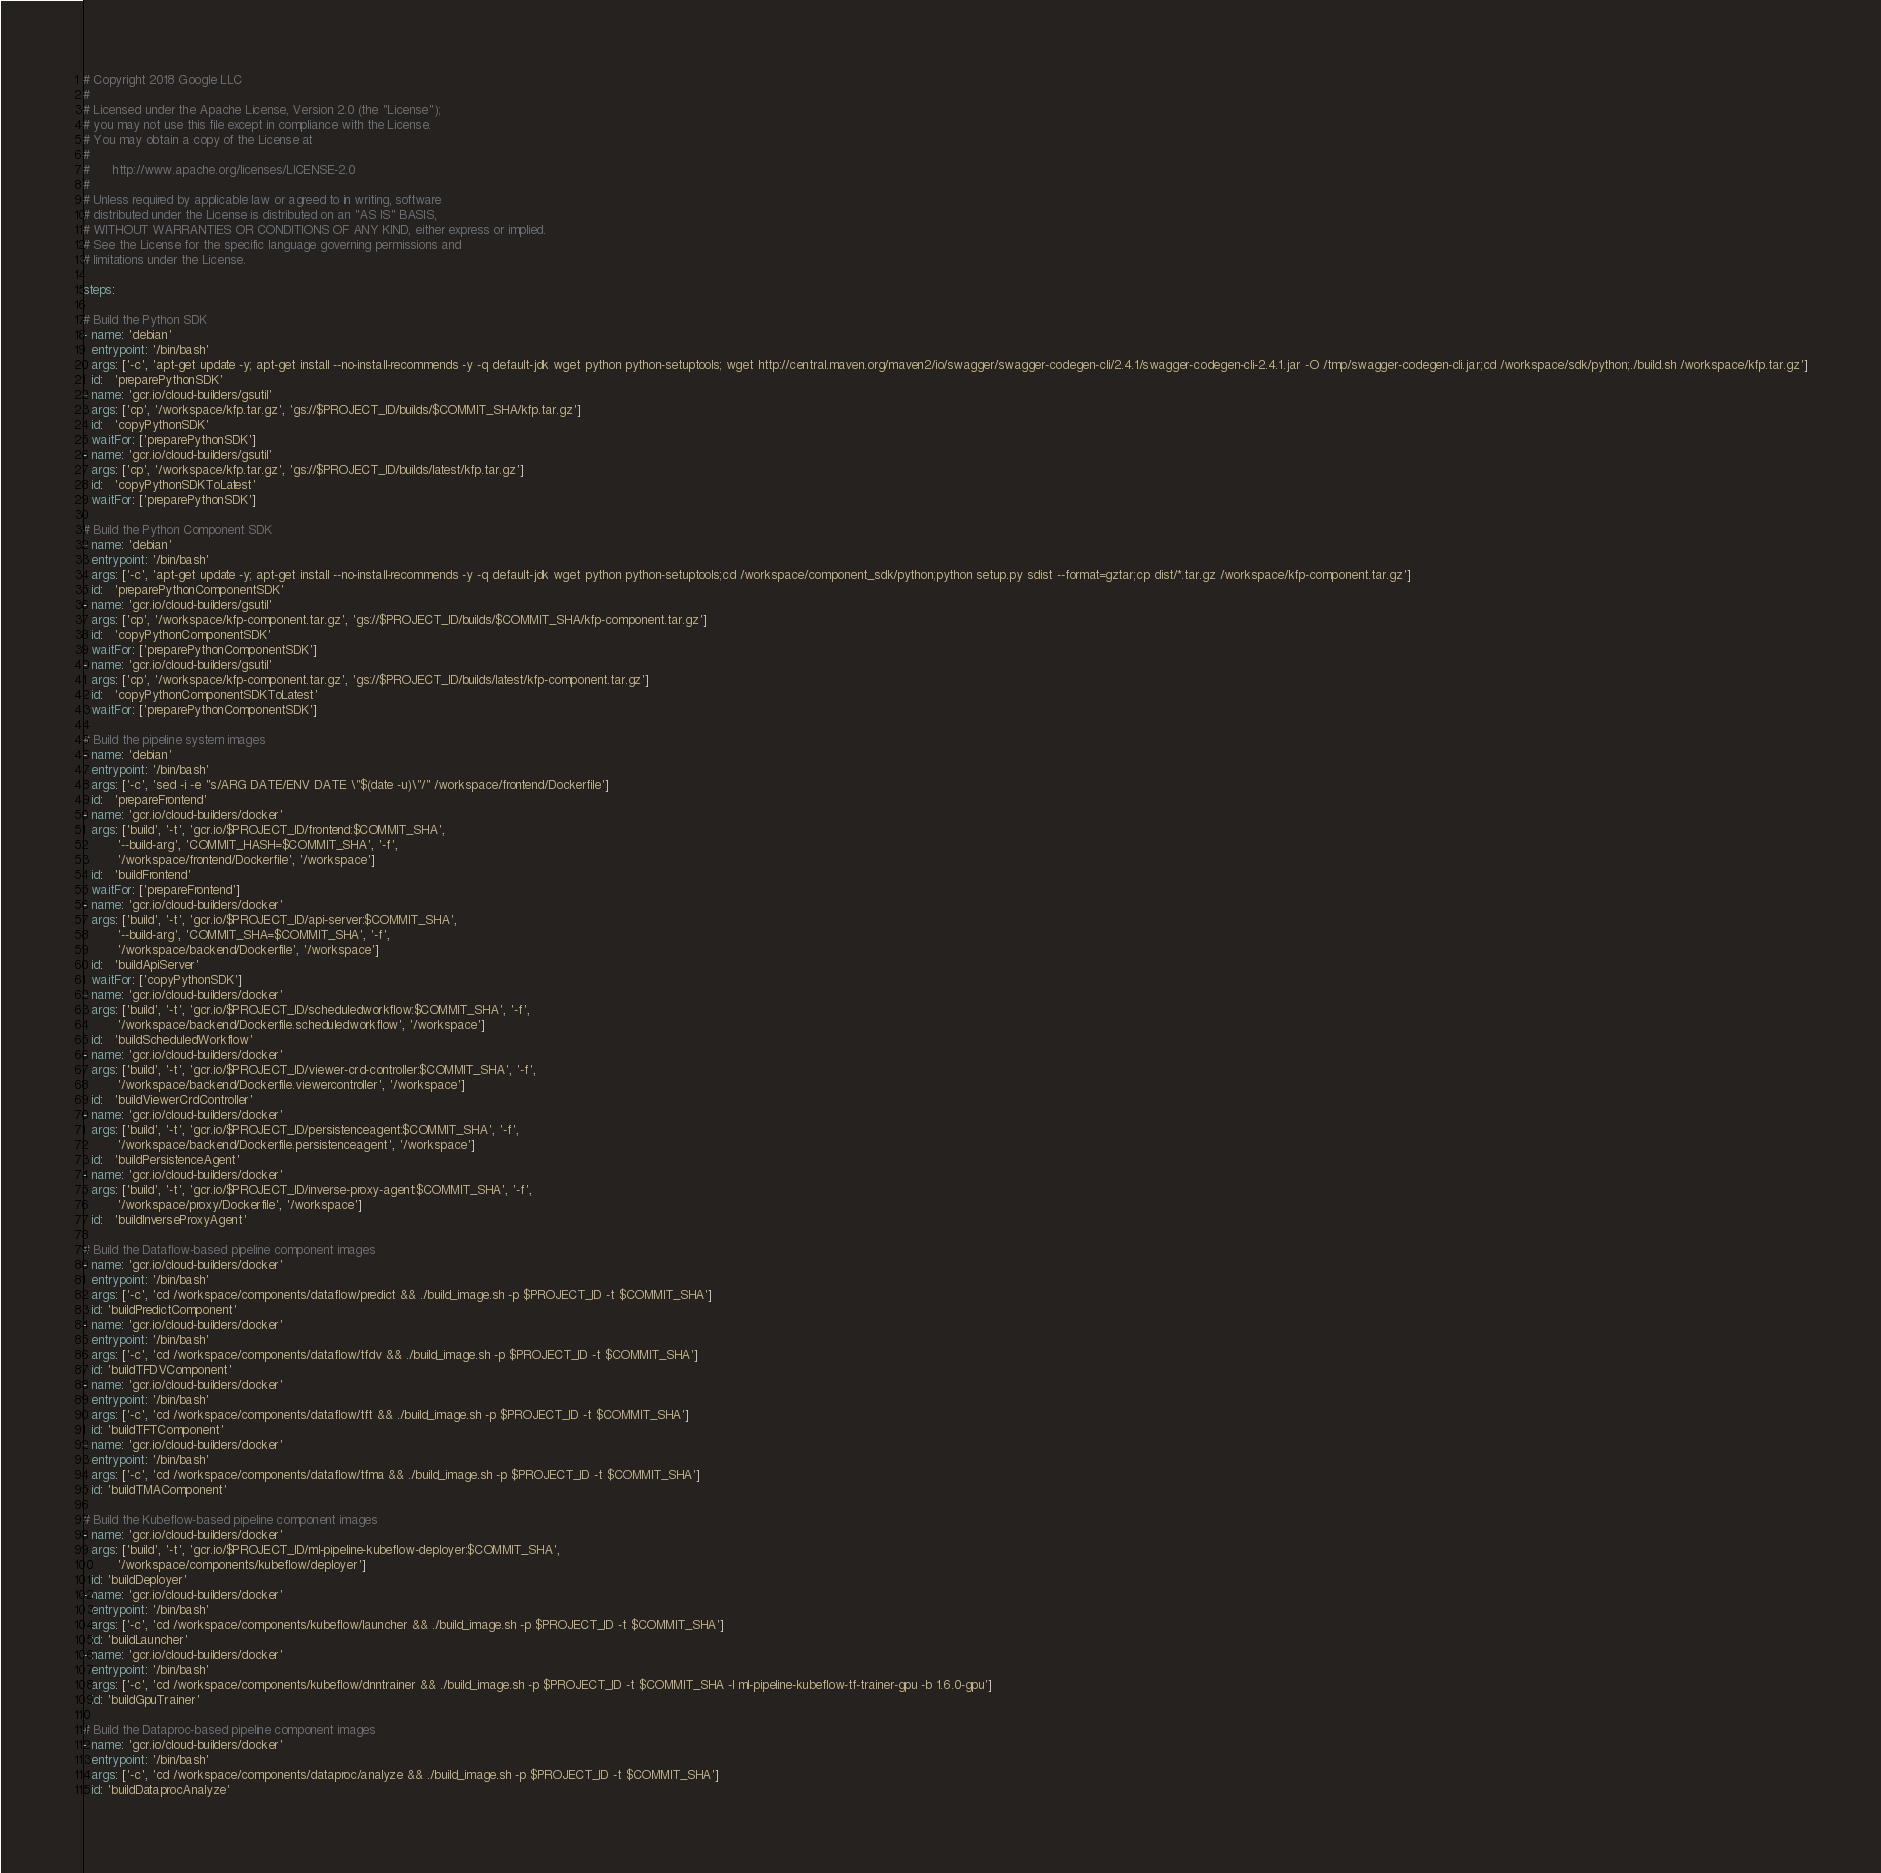Convert code to text. <code><loc_0><loc_0><loc_500><loc_500><_YAML_># Copyright 2018 Google LLC
#
# Licensed under the Apache License, Version 2.0 (the "License");
# you may not use this file except in compliance with the License.
# You may obtain a copy of the License at
#
#      http://www.apache.org/licenses/LICENSE-2.0
#
# Unless required by applicable law or agreed to in writing, software
# distributed under the License is distributed on an "AS IS" BASIS,
# WITHOUT WARRANTIES OR CONDITIONS OF ANY KIND, either express or implied.
# See the License for the specific language governing permissions and
# limitations under the License.

steps:

# Build the Python SDK
- name: 'debian'
  entrypoint: '/bin/bash'
  args: ['-c', 'apt-get update -y; apt-get install --no-install-recommends -y -q default-jdk wget python python-setuptools; wget http://central.maven.org/maven2/io/swagger/swagger-codegen-cli/2.4.1/swagger-codegen-cli-2.4.1.jar -O /tmp/swagger-codegen-cli.jar;cd /workspace/sdk/python;./build.sh /workspace/kfp.tar.gz']
  id:   'preparePythonSDK'
- name: 'gcr.io/cloud-builders/gsutil'
  args: ['cp', '/workspace/kfp.tar.gz', 'gs://$PROJECT_ID/builds/$COMMIT_SHA/kfp.tar.gz']
  id:   'copyPythonSDK'
  waitFor: ['preparePythonSDK']
- name: 'gcr.io/cloud-builders/gsutil'
  args: ['cp', '/workspace/kfp.tar.gz', 'gs://$PROJECT_ID/builds/latest/kfp.tar.gz']
  id:   'copyPythonSDKToLatest'
  waitFor: ['preparePythonSDK']

# Build the Python Component SDK
- name: 'debian'
  entrypoint: '/bin/bash'
  args: ['-c', 'apt-get update -y; apt-get install --no-install-recommends -y -q default-jdk wget python python-setuptools;cd /workspace/component_sdk/python;python setup.py sdist --format=gztar;cp dist/*.tar.gz /workspace/kfp-component.tar.gz']
  id:   'preparePythonComponentSDK'
- name: 'gcr.io/cloud-builders/gsutil'
  args: ['cp', '/workspace/kfp-component.tar.gz', 'gs://$PROJECT_ID/builds/$COMMIT_SHA/kfp-component.tar.gz']
  id:   'copyPythonComponentSDK'
  waitFor: ['preparePythonComponentSDK']
- name: 'gcr.io/cloud-builders/gsutil'
  args: ['cp', '/workspace/kfp-component.tar.gz', 'gs://$PROJECT_ID/builds/latest/kfp-component.tar.gz']
  id:   'copyPythonComponentSDKToLatest'
  waitFor: ['preparePythonComponentSDK']

# Build the pipeline system images
- name: 'debian'
  entrypoint: '/bin/bash'
  args: ['-c', 'sed -i -e "s/ARG DATE/ENV DATE \"$(date -u)\"/" /workspace/frontend/Dockerfile']
  id:   'prepareFrontend'
- name: 'gcr.io/cloud-builders/docker'
  args: ['build', '-t', 'gcr.io/$PROJECT_ID/frontend:$COMMIT_SHA',
         '--build-arg', 'COMMIT_HASH=$COMMIT_SHA', '-f',
         '/workspace/frontend/Dockerfile', '/workspace']
  id:   'buildFrontend'
  waitFor: ['prepareFrontend']
- name: 'gcr.io/cloud-builders/docker'
  args: ['build', '-t', 'gcr.io/$PROJECT_ID/api-server:$COMMIT_SHA',
         '--build-arg', 'COMMIT_SHA=$COMMIT_SHA', '-f',
         '/workspace/backend/Dockerfile', '/workspace']
  id:   'buildApiServer'
  waitFor: ['copyPythonSDK']
- name: 'gcr.io/cloud-builders/docker'
  args: ['build', '-t', 'gcr.io/$PROJECT_ID/scheduledworkflow:$COMMIT_SHA', '-f',
         '/workspace/backend/Dockerfile.scheduledworkflow', '/workspace']
  id:   'buildScheduledWorkflow'
- name: 'gcr.io/cloud-builders/docker'
  args: ['build', '-t', 'gcr.io/$PROJECT_ID/viewer-crd-controller:$COMMIT_SHA', '-f',
         '/workspace/backend/Dockerfile.viewercontroller', '/workspace']
  id:   'buildViewerCrdController'
- name: 'gcr.io/cloud-builders/docker'
  args: ['build', '-t', 'gcr.io/$PROJECT_ID/persistenceagent:$COMMIT_SHA', '-f',
         '/workspace/backend/Dockerfile.persistenceagent', '/workspace']
  id:   'buildPersistenceAgent'
- name: 'gcr.io/cloud-builders/docker'
  args: ['build', '-t', 'gcr.io/$PROJECT_ID/inverse-proxy-agent:$COMMIT_SHA', '-f',
         '/workspace/proxy/Dockerfile', '/workspace']
  id:   'buildInverseProxyAgent'

# Build the Dataflow-based pipeline component images
- name: 'gcr.io/cloud-builders/docker'
  entrypoint: '/bin/bash'
  args: ['-c', 'cd /workspace/components/dataflow/predict && ./build_image.sh -p $PROJECT_ID -t $COMMIT_SHA']
  id: 'buildPredictComponent'
- name: 'gcr.io/cloud-builders/docker'
  entrypoint: '/bin/bash'
  args: ['-c', 'cd /workspace/components/dataflow/tfdv && ./build_image.sh -p $PROJECT_ID -t $COMMIT_SHA']
  id: 'buildTFDVComponent'
- name: 'gcr.io/cloud-builders/docker'
  entrypoint: '/bin/bash'
  args: ['-c', 'cd /workspace/components/dataflow/tft && ./build_image.sh -p $PROJECT_ID -t $COMMIT_SHA']
  id: 'buildTFTComponent'
- name: 'gcr.io/cloud-builders/docker'
  entrypoint: '/bin/bash'
  args: ['-c', 'cd /workspace/components/dataflow/tfma && ./build_image.sh -p $PROJECT_ID -t $COMMIT_SHA']
  id: 'buildTMAComponent'

# Build the Kubeflow-based pipeline component images
- name: 'gcr.io/cloud-builders/docker'
  args: ['build', '-t', 'gcr.io/$PROJECT_ID/ml-pipeline-kubeflow-deployer:$COMMIT_SHA',
         '/workspace/components/kubeflow/deployer']
  id: 'buildDeployer'
- name: 'gcr.io/cloud-builders/docker'
  entrypoint: '/bin/bash'
  args: ['-c', 'cd /workspace/components/kubeflow/launcher && ./build_image.sh -p $PROJECT_ID -t $COMMIT_SHA']
  id: 'buildLauncher'
- name: 'gcr.io/cloud-builders/docker'
  entrypoint: '/bin/bash'
  args: ['-c', 'cd /workspace/components/kubeflow/dnntrainer && ./build_image.sh -p $PROJECT_ID -t $COMMIT_SHA -l ml-pipeline-kubeflow-tf-trainer-gpu -b 1.6.0-gpu']
  id: 'buildGpuTrainer'

# Build the Dataproc-based pipeline component images
- name: 'gcr.io/cloud-builders/docker'
  entrypoint: '/bin/bash'
  args: ['-c', 'cd /workspace/components/dataproc/analyze && ./build_image.sh -p $PROJECT_ID -t $COMMIT_SHA']
  id: 'buildDataprocAnalyze'</code> 